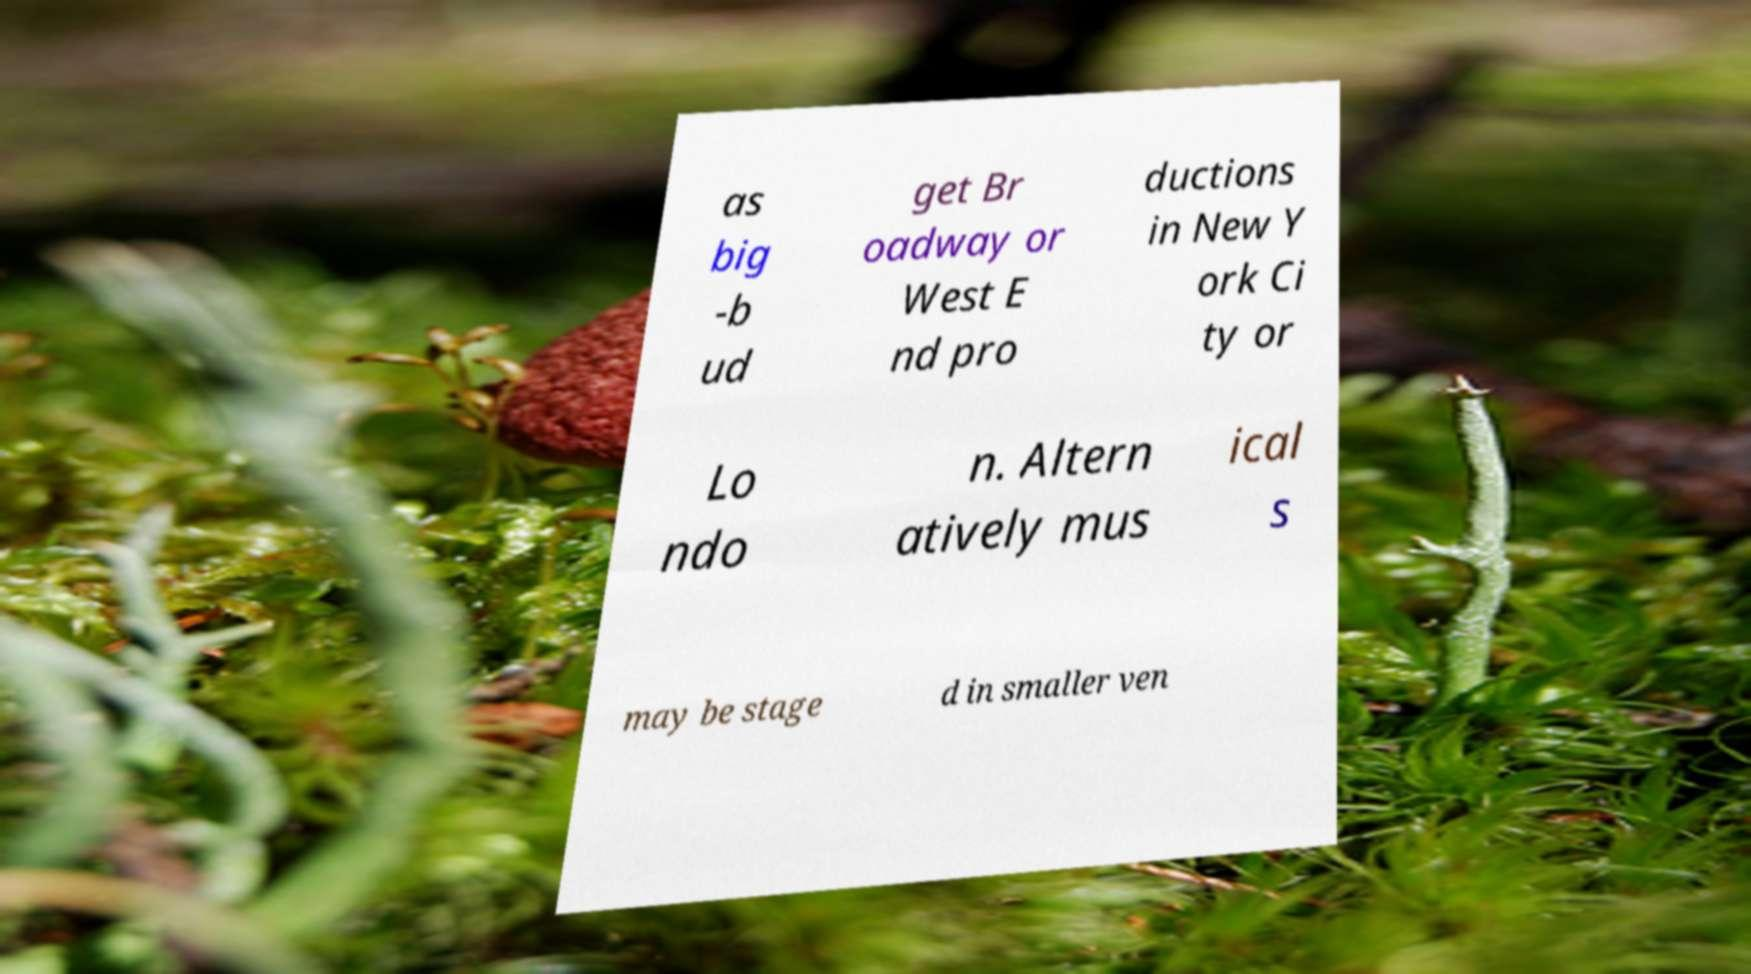For documentation purposes, I need the text within this image transcribed. Could you provide that? as big -b ud get Br oadway or West E nd pro ductions in New Y ork Ci ty or Lo ndo n. Altern atively mus ical s may be stage d in smaller ven 